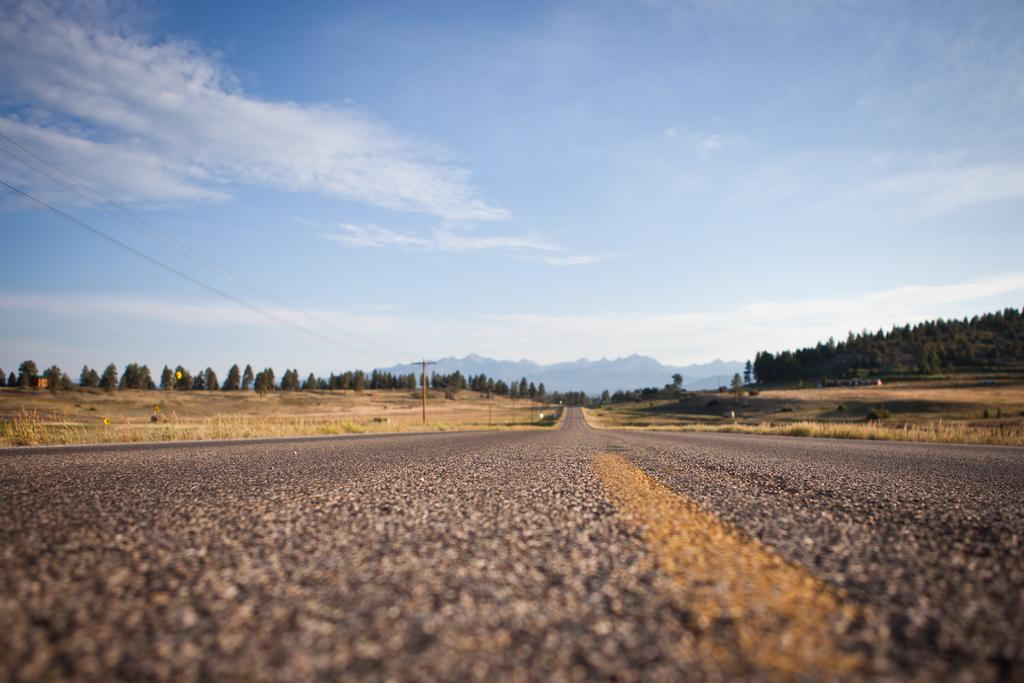What is there is a road in the middle of the image, what can you tell me about it? There is a road in the middle of the image, and it appears to be the main focus of the scene. What can be seen in the background of the image? In the background of the image, there are trees, hills, and clouds in the sky. How would you describe the landscape in the image? The landscape in the image features a road, trees, hills, and a sky with clouds. Can you tell me more about the trees in the background? The trees in the background are visible among the hills and provide a sense of the natural environment surrounding the road. What type of mouth can be seen on the wren in the image? There is no wren present in the image, and therefore no mouth to describe. 